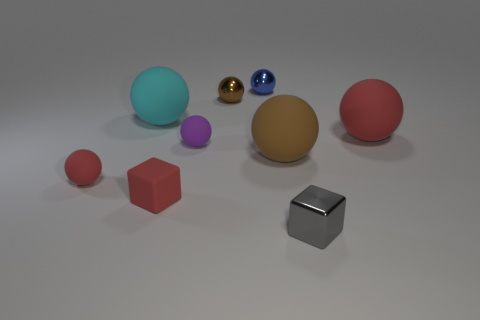Subtract all green cylinders. How many brown balls are left? 2 Subtract all cyan spheres. How many spheres are left? 6 Subtract all tiny purple spheres. How many spheres are left? 6 Add 1 large things. How many objects exist? 10 Subtract all blue spheres. Subtract all cyan cylinders. How many spheres are left? 6 Subtract all balls. How many objects are left? 2 Subtract all purple balls. Subtract all small blue shiny things. How many objects are left? 7 Add 6 metal things. How many metal things are left? 9 Add 2 brown rubber cubes. How many brown rubber cubes exist? 2 Subtract 0 green balls. How many objects are left? 9 